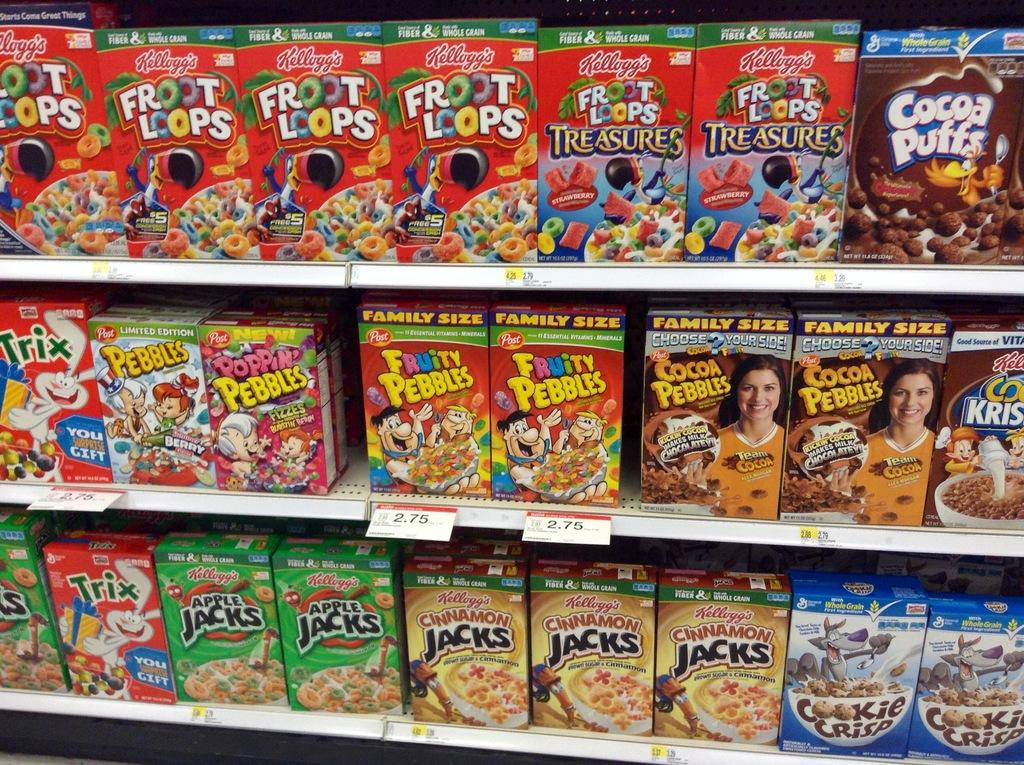<image>
Relay a brief, clear account of the picture shown. Kellogg,s Front Loops are displayed next to many other cereals 